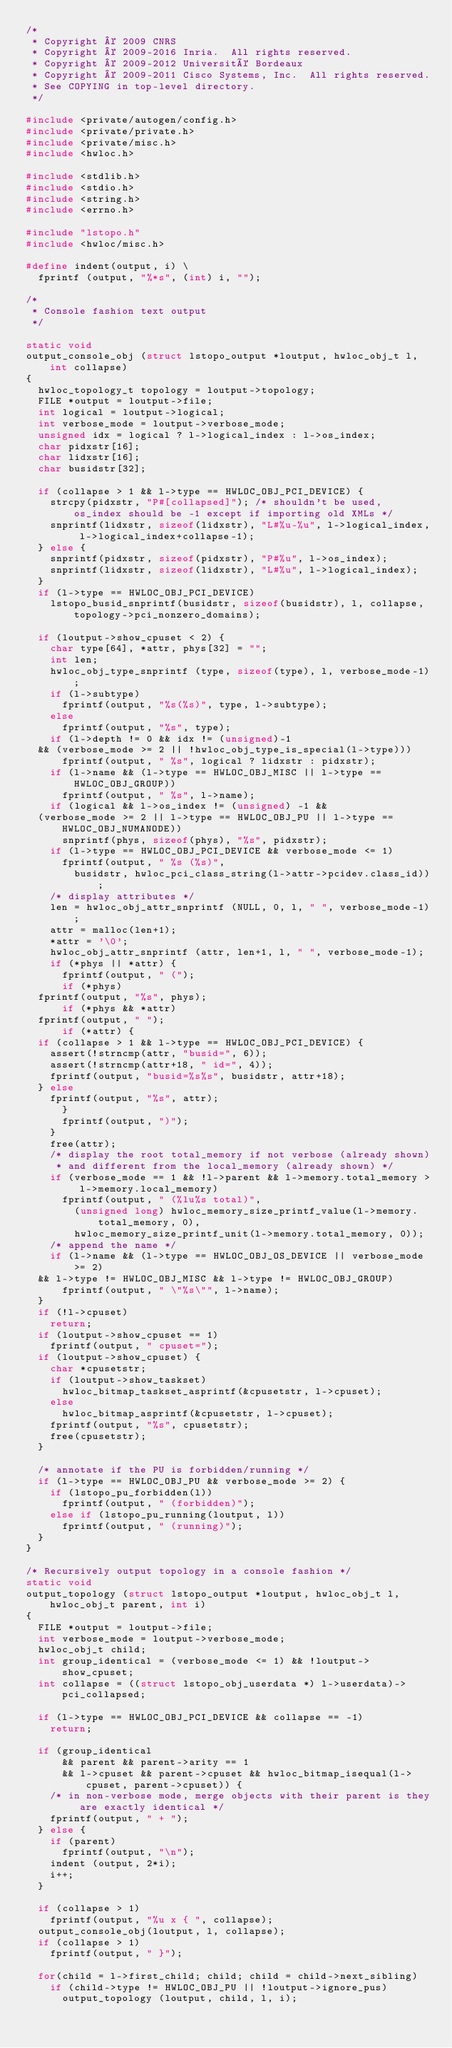Convert code to text. <code><loc_0><loc_0><loc_500><loc_500><_C_>/*
 * Copyright © 2009 CNRS
 * Copyright © 2009-2016 Inria.  All rights reserved.
 * Copyright © 2009-2012 Université Bordeaux
 * Copyright © 2009-2011 Cisco Systems, Inc.  All rights reserved.
 * See COPYING in top-level directory.
 */

#include <private/autogen/config.h>
#include <private/private.h>
#include <private/misc.h>
#include <hwloc.h>

#include <stdlib.h>
#include <stdio.h>
#include <string.h>
#include <errno.h>

#include "lstopo.h"
#include <hwloc/misc.h>

#define indent(output, i) \
  fprintf (output, "%*s", (int) i, "");

/*
 * Console fashion text output
 */

static void
output_console_obj (struct lstopo_output *loutput, hwloc_obj_t l, int collapse)
{
  hwloc_topology_t topology = loutput->topology;
  FILE *output = loutput->file;
  int logical = loutput->logical;
  int verbose_mode = loutput->verbose_mode;
  unsigned idx = logical ? l->logical_index : l->os_index;
  char pidxstr[16];
  char lidxstr[16];
  char busidstr[32];

  if (collapse > 1 && l->type == HWLOC_OBJ_PCI_DEVICE) {
    strcpy(pidxstr, "P#[collapsed]"); /* shouldn't be used, os_index should be -1 except if importing old XMLs */
    snprintf(lidxstr, sizeof(lidxstr), "L#%u-%u", l->logical_index, l->logical_index+collapse-1);
  } else {
    snprintf(pidxstr, sizeof(pidxstr), "P#%u", l->os_index);
    snprintf(lidxstr, sizeof(lidxstr), "L#%u", l->logical_index);
  }
  if (l->type == HWLOC_OBJ_PCI_DEVICE)
    lstopo_busid_snprintf(busidstr, sizeof(busidstr), l, collapse, topology->pci_nonzero_domains);

  if (loutput->show_cpuset < 2) {
    char type[64], *attr, phys[32] = "";
    int len;
    hwloc_obj_type_snprintf (type, sizeof(type), l, verbose_mode-1);
    if (l->subtype)
      fprintf(output, "%s(%s)", type, l->subtype);
    else
      fprintf(output, "%s", type);
    if (l->depth != 0 && idx != (unsigned)-1
	&& (verbose_mode >= 2 || !hwloc_obj_type_is_special(l->type)))
      fprintf(output, " %s", logical ? lidxstr : pidxstr);
    if (l->name && (l->type == HWLOC_OBJ_MISC || l->type == HWLOC_OBJ_GROUP))
      fprintf(output, " %s", l->name);
    if (logical && l->os_index != (unsigned) -1 &&
	(verbose_mode >= 2 || l->type == HWLOC_OBJ_PU || l->type == HWLOC_OBJ_NUMANODE))
      snprintf(phys, sizeof(phys), "%s", pidxstr);
    if (l->type == HWLOC_OBJ_PCI_DEVICE && verbose_mode <= 1)
      fprintf(output, " %s (%s)",
	      busidstr, hwloc_pci_class_string(l->attr->pcidev.class_id));
    /* display attributes */
    len = hwloc_obj_attr_snprintf (NULL, 0, l, " ", verbose_mode-1);
    attr = malloc(len+1);
    *attr = '\0';
    hwloc_obj_attr_snprintf (attr, len+1, l, " ", verbose_mode-1);
    if (*phys || *attr) {
      fprintf(output, " (");
      if (*phys)
	fprintf(output, "%s", phys);
      if (*phys && *attr)
	fprintf(output, " ");
      if (*attr) {
	if (collapse > 1 && l->type == HWLOC_OBJ_PCI_DEVICE) {
	  assert(!strncmp(attr, "busid=", 6));
	  assert(!strncmp(attr+18, " id=", 4));
	  fprintf(output, "busid=%s%s", busidstr, attr+18);
	} else
	  fprintf(output, "%s", attr);
      }
      fprintf(output, ")");
    }
    free(attr);
    /* display the root total_memory if not verbose (already shown)
     * and different from the local_memory (already shown) */
    if (verbose_mode == 1 && !l->parent && l->memory.total_memory > l->memory.local_memory)
      fprintf(output, " (%lu%s total)",
	      (unsigned long) hwloc_memory_size_printf_value(l->memory.total_memory, 0),
	      hwloc_memory_size_printf_unit(l->memory.total_memory, 0));
    /* append the name */
    if (l->name && (l->type == HWLOC_OBJ_OS_DEVICE || verbose_mode >= 2)
	&& l->type != HWLOC_OBJ_MISC && l->type != HWLOC_OBJ_GROUP)
      fprintf(output, " \"%s\"", l->name);
  }
  if (!l->cpuset)
    return;
  if (loutput->show_cpuset == 1)
    fprintf(output, " cpuset=");
  if (loutput->show_cpuset) {
    char *cpusetstr;
    if (loutput->show_taskset)
      hwloc_bitmap_taskset_asprintf(&cpusetstr, l->cpuset);
    else
      hwloc_bitmap_asprintf(&cpusetstr, l->cpuset);
    fprintf(output, "%s", cpusetstr);
    free(cpusetstr);
  }

  /* annotate if the PU is forbidden/running */
  if (l->type == HWLOC_OBJ_PU && verbose_mode >= 2) {
    if (lstopo_pu_forbidden(l))
      fprintf(output, " (forbidden)");
    else if (lstopo_pu_running(loutput, l))
      fprintf(output, " (running)");
  }
}

/* Recursively output topology in a console fashion */
static void
output_topology (struct lstopo_output *loutput, hwloc_obj_t l, hwloc_obj_t parent, int i)
{
  FILE *output = loutput->file;
  int verbose_mode = loutput->verbose_mode;
  hwloc_obj_t child;
  int group_identical = (verbose_mode <= 1) && !loutput->show_cpuset;
  int collapse = ((struct lstopo_obj_userdata *) l->userdata)->pci_collapsed;

  if (l->type == HWLOC_OBJ_PCI_DEVICE && collapse == -1)
    return;

  if (group_identical
      && parent && parent->arity == 1
      && l->cpuset && parent->cpuset && hwloc_bitmap_isequal(l->cpuset, parent->cpuset)) {
    /* in non-verbose mode, merge objects with their parent is they are exactly identical */
    fprintf(output, " + ");
  } else {
    if (parent)
      fprintf(output, "\n");
    indent (output, 2*i);
    i++;
  }

  if (collapse > 1)
    fprintf(output, "%u x { ", collapse);
  output_console_obj(loutput, l, collapse);
  if (collapse > 1)
    fprintf(output, " }");

  for(child = l->first_child; child; child = child->next_sibling)
    if (child->type != HWLOC_OBJ_PU || !loutput->ignore_pus)
      output_topology (loutput, child, l, i);</code> 